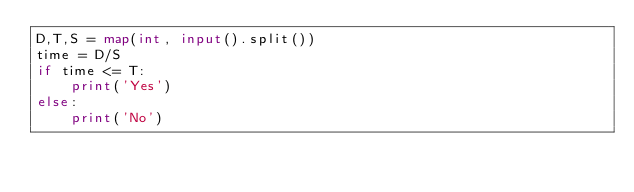<code> <loc_0><loc_0><loc_500><loc_500><_Python_>D,T,S = map(int, input().split())
time = D/S
if time <= T:
    print('Yes')
else:
    print('No')</code> 